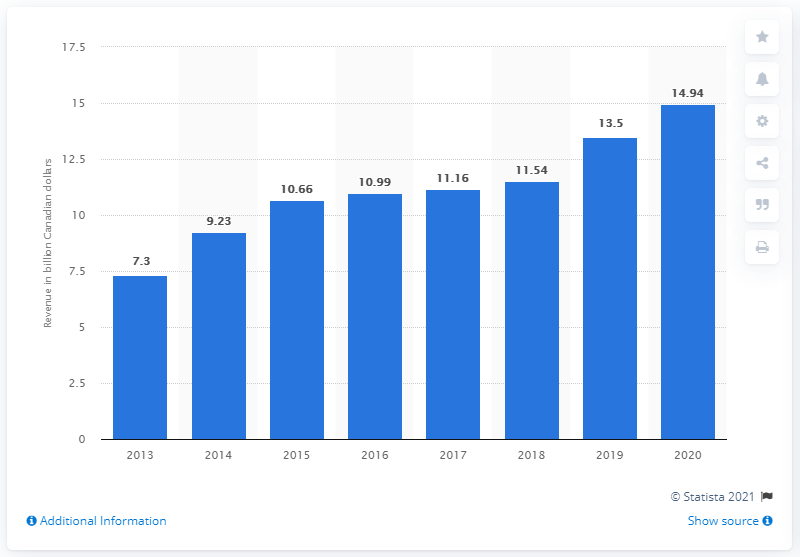Point out several critical features in this image. In 2020, Saputo Inc.'s revenue in Canadian dollars was 14.94. In 2013, the revenue of Saputo Inc. was 7.3 billion. 